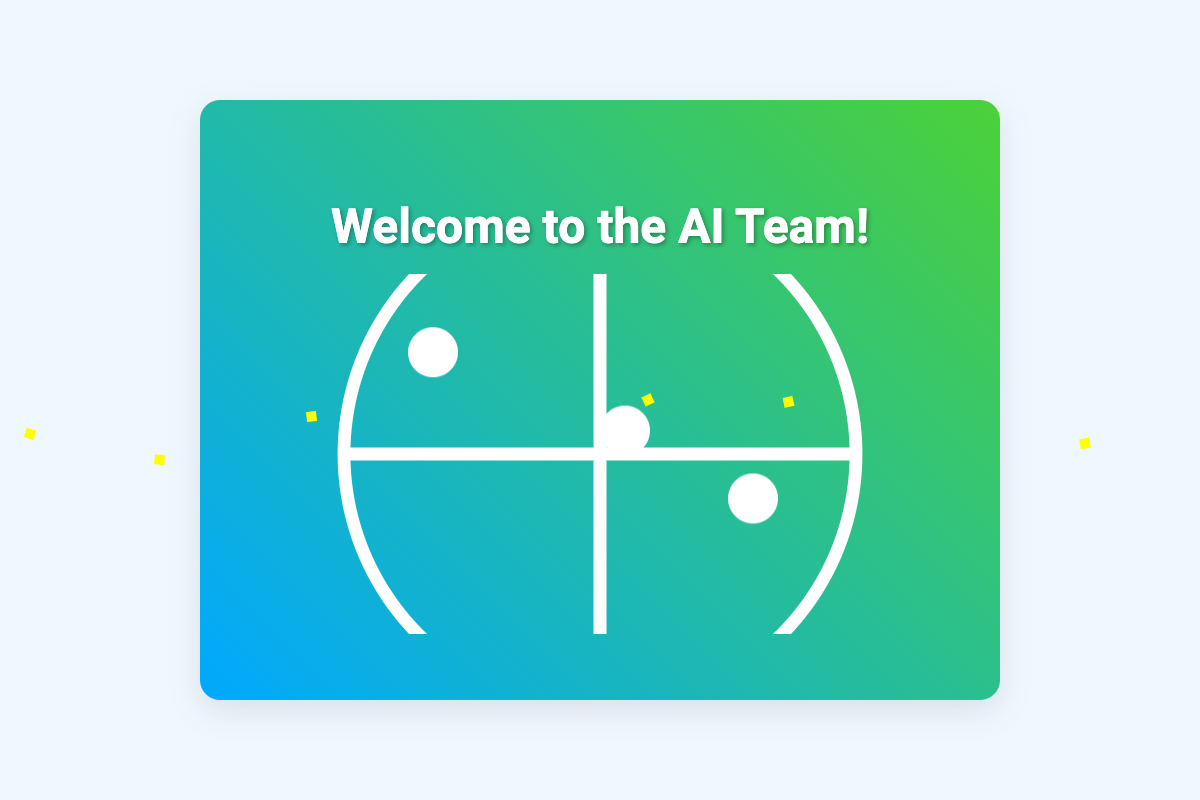What is the name of the team member who leads AI research? The document mentions Dr. Sarah Johnson as the Lead AI Researcher.
Answer: Dr. Sarah Johnson How many exciting projects are listed in the card? The document includes three exciting projects described in the projects section.
Answer: 3 What is the main focus of the project titled "AI-Driven Healthcare Solutions"? The description for this project indicates it involves creating AI models for predictive diagnoses and personalized treatment plans.
Answer: Predictive diagnoses What color is the background of the card's front? The front of the card features a gradient background in the colors of blue and green.
Answer: Blue and green What does the card say about the new team member? The card expresses a warm welcome and indicates excitement about the new team member joining.
Answer: Welcome and excitement Who is responsible for machine learning algorithms on the team? Tom Fernandez is identified as the AI Engineer responsible for machine learning algorithms.
Answer: Tom Fernandez What type of illustrations accompany the message inside the card? The illustrations depicted inside the card are shown as illustrations of collaborative AI and robotics endeavors.
Answer: Collaborative AI and robotics What is the overall theme of the card? The theme conveys a welcoming atmosphere to a new team member in an AI context, emphasizing creativity and teamwork.
Answer: AI teamwork and creativity 